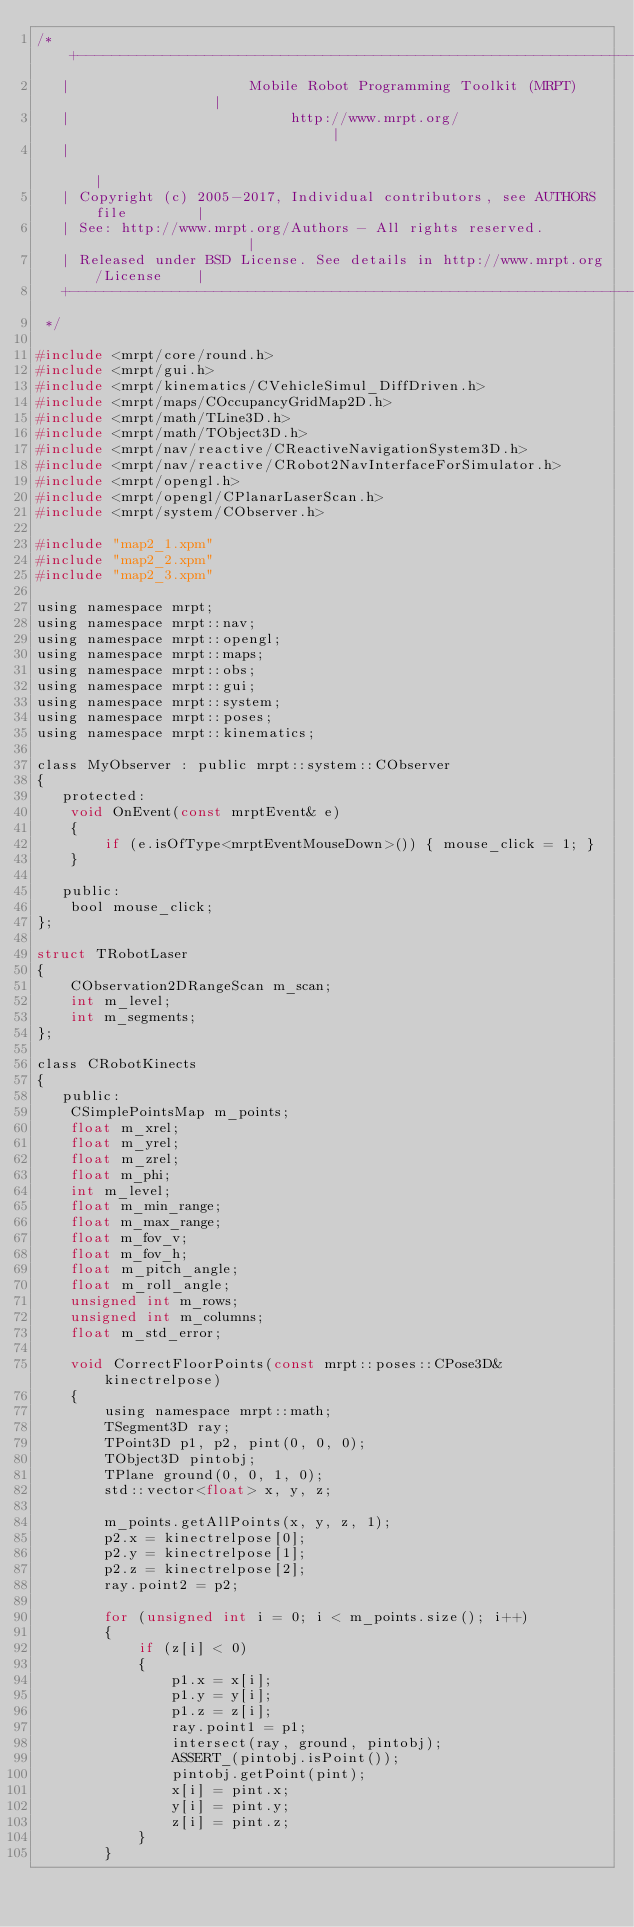Convert code to text. <code><loc_0><loc_0><loc_500><loc_500><_C_>/* +---------------------------------------------------------------------------+
   |                     Mobile Robot Programming Toolkit (MRPT)               |
   |                          http://www.mrpt.org/                             |
   |                                                                           |
   | Copyright (c) 2005-2017, Individual contributors, see AUTHORS file        |
   | See: http://www.mrpt.org/Authors - All rights reserved.                   |
   | Released under BSD License. See details in http://www.mrpt.org/License    |
   +---------------------------------------------------------------------------+
 */

#include <mrpt/core/round.h>
#include <mrpt/gui.h>
#include <mrpt/kinematics/CVehicleSimul_DiffDriven.h>
#include <mrpt/maps/COccupancyGridMap2D.h>
#include <mrpt/math/TLine3D.h>
#include <mrpt/math/TObject3D.h>
#include <mrpt/nav/reactive/CReactiveNavigationSystem3D.h>
#include <mrpt/nav/reactive/CRobot2NavInterfaceForSimulator.h>
#include <mrpt/opengl.h>
#include <mrpt/opengl/CPlanarLaserScan.h>
#include <mrpt/system/CObserver.h>

#include "map2_1.xpm"
#include "map2_2.xpm"
#include "map2_3.xpm"

using namespace mrpt;
using namespace mrpt::nav;
using namespace mrpt::opengl;
using namespace mrpt::maps;
using namespace mrpt::obs;
using namespace mrpt::gui;
using namespace mrpt::system;
using namespace mrpt::poses;
using namespace mrpt::kinematics;

class MyObserver : public mrpt::system::CObserver
{
   protected:
	void OnEvent(const mrptEvent& e)
	{
		if (e.isOfType<mrptEventMouseDown>()) { mouse_click = 1; }
	}

   public:
	bool mouse_click;
};

struct TRobotLaser
{
	CObservation2DRangeScan m_scan;
	int m_level;
	int m_segments;
};

class CRobotKinects
{
   public:
	CSimplePointsMap m_points;
	float m_xrel;
	float m_yrel;
	float m_zrel;
	float m_phi;
	int m_level;
	float m_min_range;
	float m_max_range;
	float m_fov_v;
	float m_fov_h;
	float m_pitch_angle;
	float m_roll_angle;
	unsigned int m_rows;
	unsigned int m_columns;
	float m_std_error;

	void CorrectFloorPoints(const mrpt::poses::CPose3D& kinectrelpose)
	{
		using namespace mrpt::math;
		TSegment3D ray;
		TPoint3D p1, p2, pint(0, 0, 0);
		TObject3D pintobj;
		TPlane ground(0, 0, 1, 0);
		std::vector<float> x, y, z;

		m_points.getAllPoints(x, y, z, 1);
		p2.x = kinectrelpose[0];
		p2.y = kinectrelpose[1];
		p2.z = kinectrelpose[2];
		ray.point2 = p2;

		for (unsigned int i = 0; i < m_points.size(); i++)
		{
			if (z[i] < 0)
			{
				p1.x = x[i];
				p1.y = y[i];
				p1.z = z[i];
				ray.point1 = p1;
				intersect(ray, ground, pintobj);
				ASSERT_(pintobj.isPoint());
				pintobj.getPoint(pint);
				x[i] = pint.x;
				y[i] = pint.y;
				z[i] = pint.z;
			}
		}</code> 